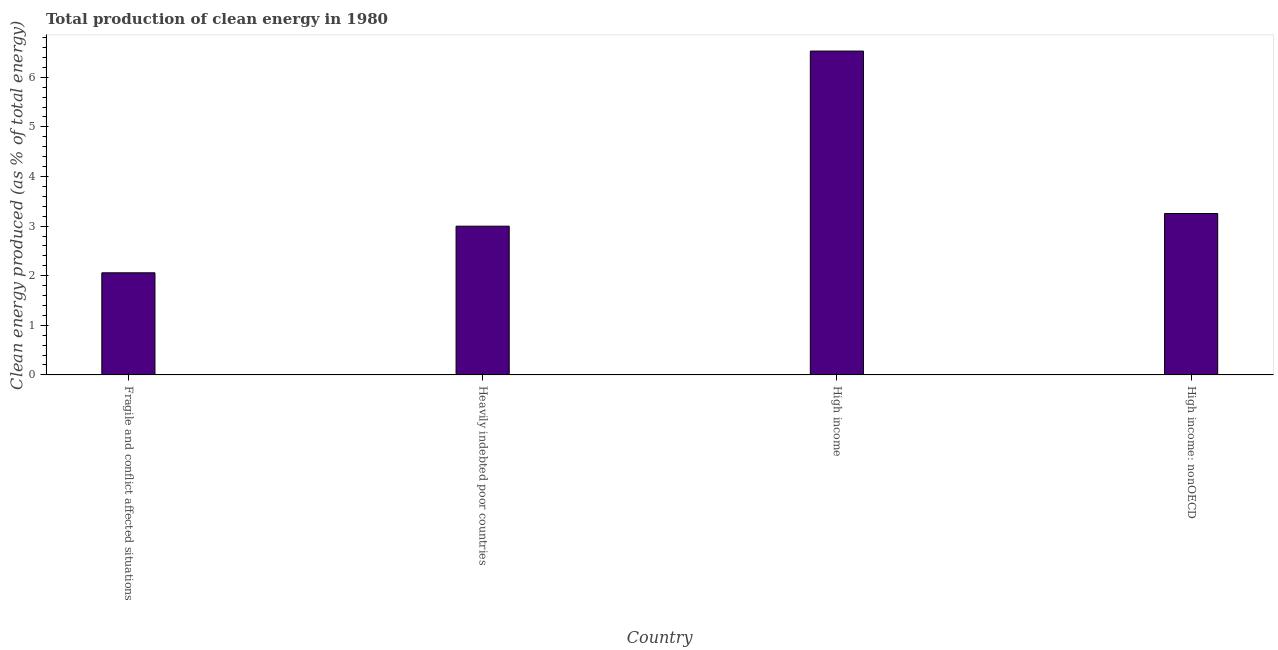What is the title of the graph?
Your answer should be compact. Total production of clean energy in 1980. What is the label or title of the X-axis?
Ensure brevity in your answer.  Country. What is the label or title of the Y-axis?
Offer a terse response. Clean energy produced (as % of total energy). What is the production of clean energy in Heavily indebted poor countries?
Provide a succinct answer. 3. Across all countries, what is the maximum production of clean energy?
Ensure brevity in your answer.  6.53. Across all countries, what is the minimum production of clean energy?
Ensure brevity in your answer.  2.06. In which country was the production of clean energy minimum?
Offer a terse response. Fragile and conflict affected situations. What is the sum of the production of clean energy?
Your answer should be compact. 14.84. What is the difference between the production of clean energy in Heavily indebted poor countries and High income: nonOECD?
Your answer should be compact. -0.26. What is the average production of clean energy per country?
Offer a very short reply. 3.71. What is the median production of clean energy?
Offer a terse response. 3.13. In how many countries, is the production of clean energy greater than 6.2 %?
Your response must be concise. 1. What is the ratio of the production of clean energy in High income to that in High income: nonOECD?
Give a very brief answer. 2.01. Is the difference between the production of clean energy in High income and High income: nonOECD greater than the difference between any two countries?
Offer a very short reply. No. What is the difference between the highest and the second highest production of clean energy?
Your answer should be very brief. 3.27. Is the sum of the production of clean energy in Fragile and conflict affected situations and High income greater than the maximum production of clean energy across all countries?
Provide a succinct answer. Yes. What is the difference between the highest and the lowest production of clean energy?
Make the answer very short. 4.47. In how many countries, is the production of clean energy greater than the average production of clean energy taken over all countries?
Keep it short and to the point. 1. Are all the bars in the graph horizontal?
Provide a succinct answer. No. What is the difference between two consecutive major ticks on the Y-axis?
Keep it short and to the point. 1. Are the values on the major ticks of Y-axis written in scientific E-notation?
Provide a short and direct response. No. What is the Clean energy produced (as % of total energy) in Fragile and conflict affected situations?
Ensure brevity in your answer.  2.06. What is the Clean energy produced (as % of total energy) in Heavily indebted poor countries?
Ensure brevity in your answer.  3. What is the Clean energy produced (as % of total energy) of High income?
Your answer should be compact. 6.53. What is the Clean energy produced (as % of total energy) in High income: nonOECD?
Ensure brevity in your answer.  3.25. What is the difference between the Clean energy produced (as % of total energy) in Fragile and conflict affected situations and Heavily indebted poor countries?
Your answer should be very brief. -0.94. What is the difference between the Clean energy produced (as % of total energy) in Fragile and conflict affected situations and High income?
Provide a short and direct response. -4.47. What is the difference between the Clean energy produced (as % of total energy) in Fragile and conflict affected situations and High income: nonOECD?
Your answer should be compact. -1.19. What is the difference between the Clean energy produced (as % of total energy) in Heavily indebted poor countries and High income?
Provide a short and direct response. -3.53. What is the difference between the Clean energy produced (as % of total energy) in Heavily indebted poor countries and High income: nonOECD?
Provide a succinct answer. -0.26. What is the difference between the Clean energy produced (as % of total energy) in High income and High income: nonOECD?
Your response must be concise. 3.28. What is the ratio of the Clean energy produced (as % of total energy) in Fragile and conflict affected situations to that in Heavily indebted poor countries?
Ensure brevity in your answer.  0.69. What is the ratio of the Clean energy produced (as % of total energy) in Fragile and conflict affected situations to that in High income?
Ensure brevity in your answer.  0.32. What is the ratio of the Clean energy produced (as % of total energy) in Fragile and conflict affected situations to that in High income: nonOECD?
Provide a succinct answer. 0.63. What is the ratio of the Clean energy produced (as % of total energy) in Heavily indebted poor countries to that in High income?
Keep it short and to the point. 0.46. What is the ratio of the Clean energy produced (as % of total energy) in Heavily indebted poor countries to that in High income: nonOECD?
Make the answer very short. 0.92. What is the ratio of the Clean energy produced (as % of total energy) in High income to that in High income: nonOECD?
Offer a terse response. 2.01. 